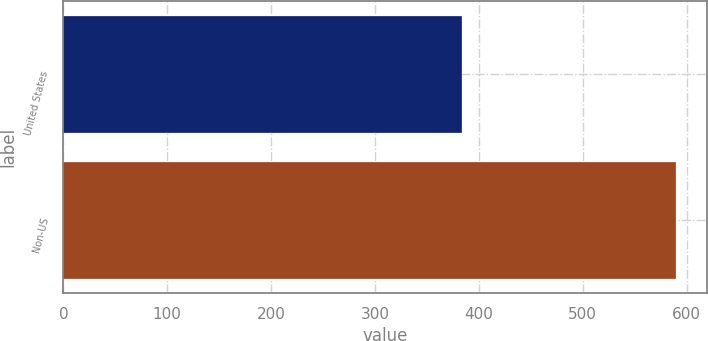<chart> <loc_0><loc_0><loc_500><loc_500><bar_chart><fcel>United States<fcel>Non-US<nl><fcel>384<fcel>590<nl></chart> 